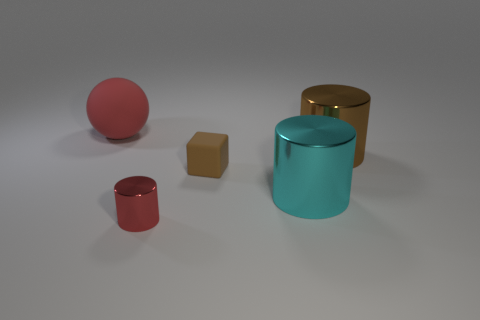Add 2 large brown objects. How many objects exist? 7 Subtract all big cylinders. How many cylinders are left? 1 Subtract all yellow cylinders. Subtract all cyan cubes. How many cylinders are left? 3 Subtract all cylinders. How many objects are left? 2 Add 1 matte balls. How many matte balls exist? 2 Subtract 0 cyan spheres. How many objects are left? 5 Subtract all tiny brown things. Subtract all big things. How many objects are left? 1 Add 4 tiny red things. How many tiny red things are left? 5 